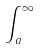Convert formula to latex. <formula><loc_0><loc_0><loc_500><loc_500>\int _ { a } ^ { \infty }</formula> 